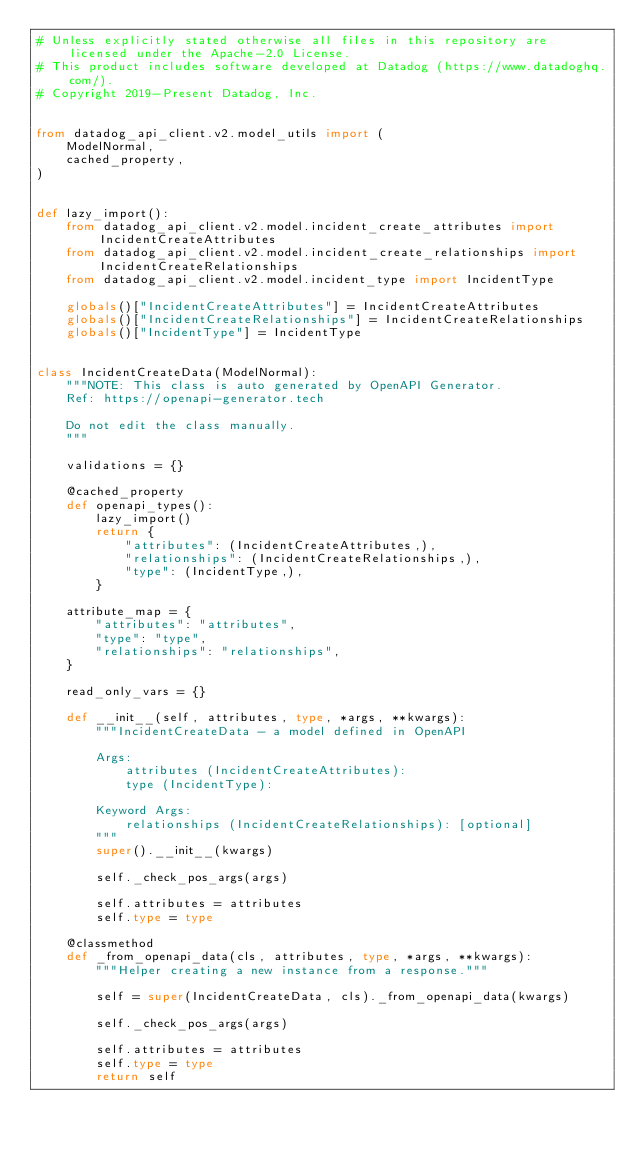Convert code to text. <code><loc_0><loc_0><loc_500><loc_500><_Python_># Unless explicitly stated otherwise all files in this repository are licensed under the Apache-2.0 License.
# This product includes software developed at Datadog (https://www.datadoghq.com/).
# Copyright 2019-Present Datadog, Inc.


from datadog_api_client.v2.model_utils import (
    ModelNormal,
    cached_property,
)


def lazy_import():
    from datadog_api_client.v2.model.incident_create_attributes import IncidentCreateAttributes
    from datadog_api_client.v2.model.incident_create_relationships import IncidentCreateRelationships
    from datadog_api_client.v2.model.incident_type import IncidentType

    globals()["IncidentCreateAttributes"] = IncidentCreateAttributes
    globals()["IncidentCreateRelationships"] = IncidentCreateRelationships
    globals()["IncidentType"] = IncidentType


class IncidentCreateData(ModelNormal):
    """NOTE: This class is auto generated by OpenAPI Generator.
    Ref: https://openapi-generator.tech

    Do not edit the class manually.
    """

    validations = {}

    @cached_property
    def openapi_types():
        lazy_import()
        return {
            "attributes": (IncidentCreateAttributes,),
            "relationships": (IncidentCreateRelationships,),
            "type": (IncidentType,),
        }

    attribute_map = {
        "attributes": "attributes",
        "type": "type",
        "relationships": "relationships",
    }

    read_only_vars = {}

    def __init__(self, attributes, type, *args, **kwargs):
        """IncidentCreateData - a model defined in OpenAPI

        Args:
            attributes (IncidentCreateAttributes):
            type (IncidentType):

        Keyword Args:
            relationships (IncidentCreateRelationships): [optional]
        """
        super().__init__(kwargs)

        self._check_pos_args(args)

        self.attributes = attributes
        self.type = type

    @classmethod
    def _from_openapi_data(cls, attributes, type, *args, **kwargs):
        """Helper creating a new instance from a response."""

        self = super(IncidentCreateData, cls)._from_openapi_data(kwargs)

        self._check_pos_args(args)

        self.attributes = attributes
        self.type = type
        return self
</code> 